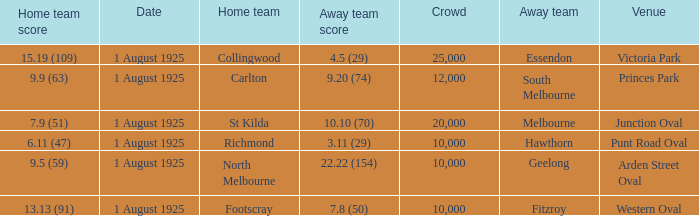5 (29), how large was the crowd? 1.0. 